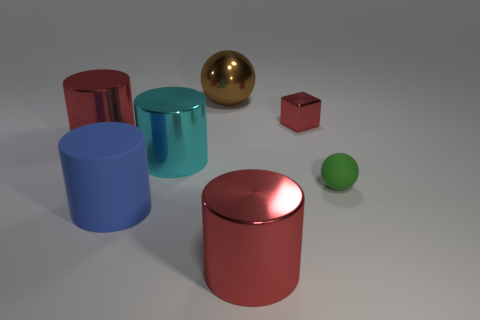What is the color of the metal object that is both to the right of the large brown object and in front of the tiny red cube?
Ensure brevity in your answer.  Red. What number of objects are small blue objects or big red shiny things?
Provide a succinct answer. 2. How many tiny objects are green rubber spheres or blue matte cylinders?
Your answer should be very brief. 1. Is there anything else that has the same color as the metal block?
Provide a succinct answer. Yes. What is the size of the thing that is in front of the green object and on the right side of the cyan thing?
Provide a succinct answer. Large. There is a large shiny object in front of the large blue cylinder; is its color the same as the large thing to the left of the blue thing?
Provide a succinct answer. Yes. How many other things are the same material as the big sphere?
Make the answer very short. 4. What is the shape of the thing that is in front of the small matte sphere and left of the brown metallic thing?
Keep it short and to the point. Cylinder. There is a tiny shiny object; does it have the same color as the large object that is in front of the large rubber cylinder?
Make the answer very short. Yes. There is a red metallic cylinder in front of the blue cylinder; is its size the same as the large blue rubber cylinder?
Your answer should be very brief. Yes. 